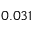Convert formula to latex. <formula><loc_0><loc_0><loc_500><loc_500>0 . 0 3 1</formula> 